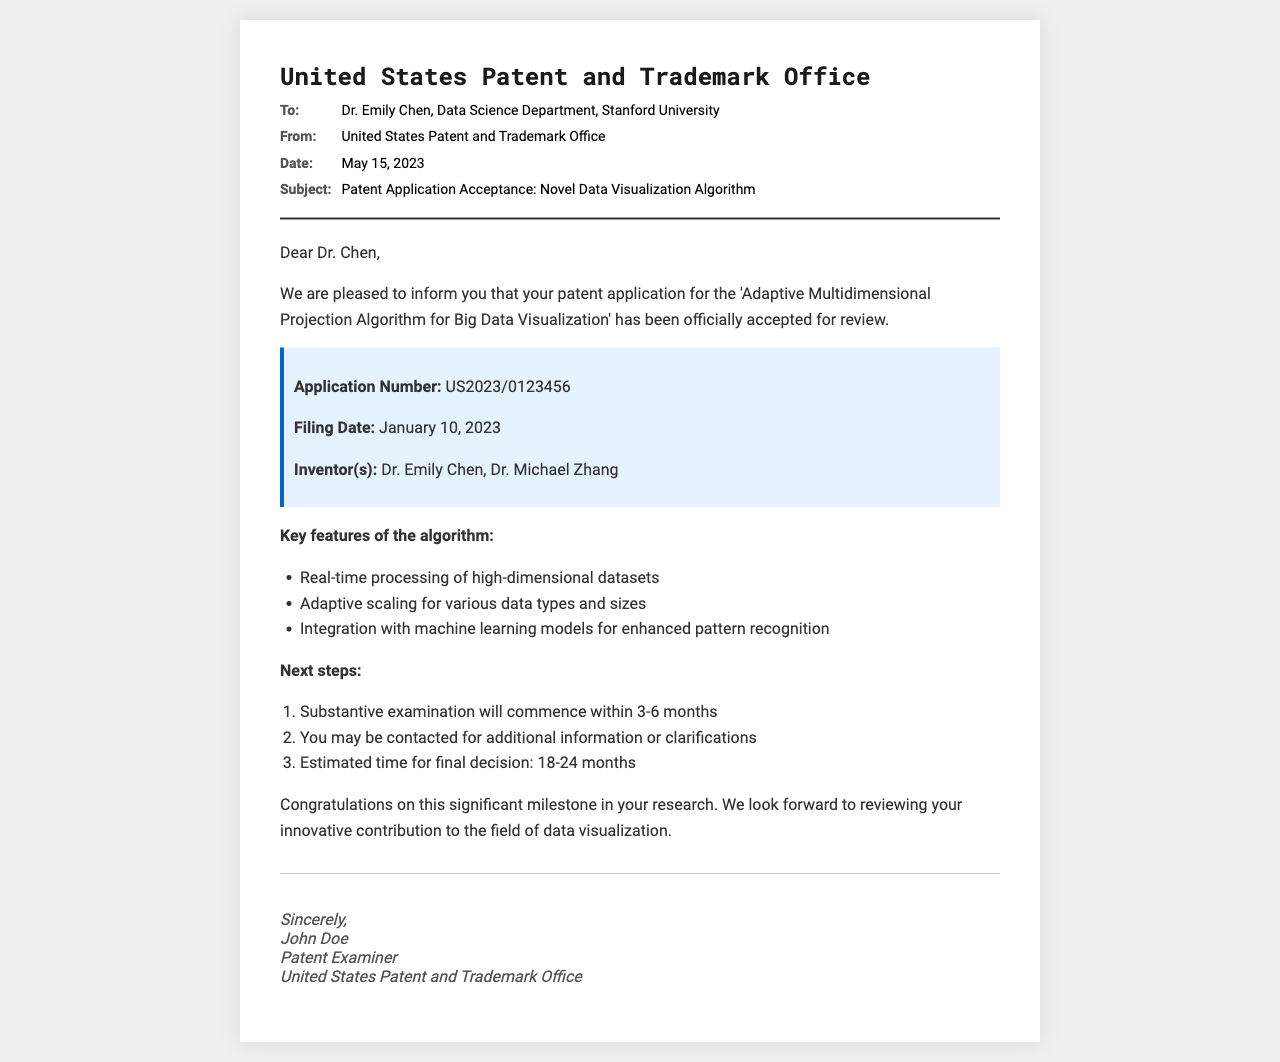What is the name of the algorithm? The algorithm is referred to as the 'Adaptive Multidimensional Projection Algorithm for Big Data Visualization' in the document.
Answer: Adaptive Multidimensional Projection Algorithm for Big Data Visualization What is the application number? The application number is listed in the document as US2023/0123456.
Answer: US2023/0123456 Who are the inventors? The document specifies the inventors as Dr. Emily Chen and Dr. Michael Zhang.
Answer: Dr. Emily Chen, Dr. Michael Zhang When was the patent application filed? The filing date is provided in the document as January 10, 2023.
Answer: January 10, 2023 What are the key features of the algorithm? The document lists three key features, including real-time processing, adaptive scaling, and integration with machine learning models.
Answer: Real-time processing of high-dimensional datasets, adaptive scaling for various data types and sizes, integration with machine learning models for enhanced pattern recognition What is the estimated time for a final decision? The estimated time for a final decision is found in the document as 18-24 months.
Answer: 18-24 months What is the name of the sender? The sender's name is mentioned as John Doe in the closing of the document.
Answer: John Doe What will happen after 3-6 months? The document states that substantive examination will commence within this time frame.
Answer: Substantive examination will commence within 3-6 months What department is Dr. Chen affiliated with? The document specifies that Dr. Chen is affiliated with the Data Science Department at Stanford University.
Answer: Data Science Department, Stanford University 